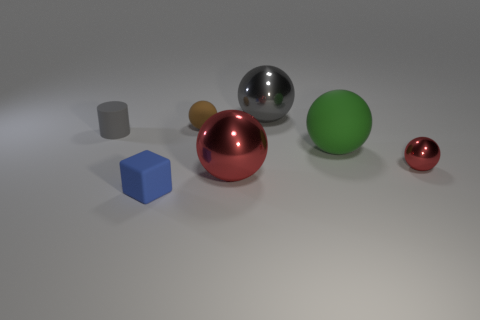Subtract all rubber balls. How many balls are left? 3 Subtract all blocks. How many objects are left? 6 Subtract all gray spheres. How many spheres are left? 4 Add 1 tiny brown rubber balls. How many tiny brown rubber balls exist? 2 Add 1 small gray cylinders. How many objects exist? 8 Subtract 0 brown blocks. How many objects are left? 7 Subtract 1 blocks. How many blocks are left? 0 Subtract all brown balls. Subtract all purple blocks. How many balls are left? 4 Subtract all blue blocks. How many purple cylinders are left? 0 Subtract all metal spheres. Subtract all large red things. How many objects are left? 3 